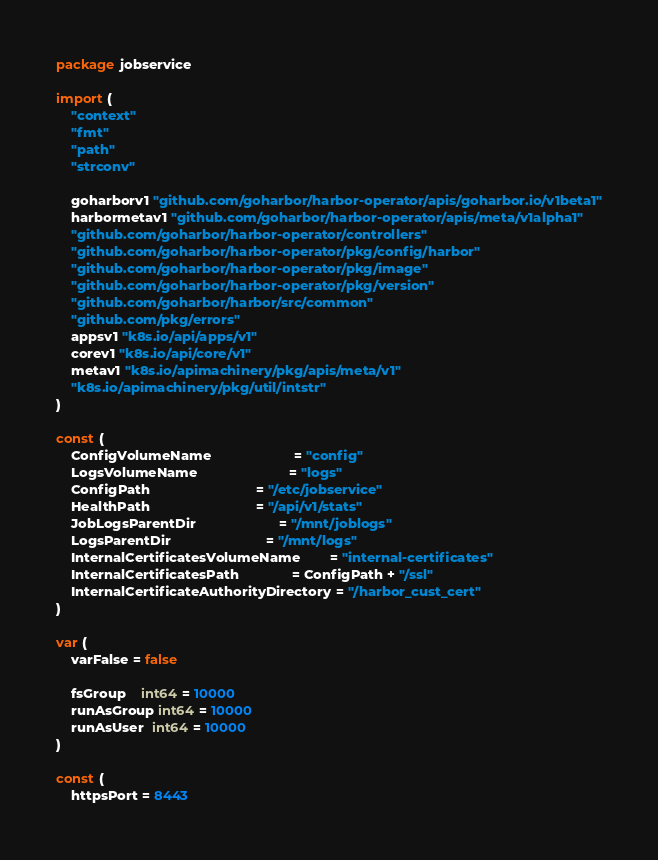Convert code to text. <code><loc_0><loc_0><loc_500><loc_500><_Go_>package jobservice

import (
	"context"
	"fmt"
	"path"
	"strconv"

	goharborv1 "github.com/goharbor/harbor-operator/apis/goharbor.io/v1beta1"
	harbormetav1 "github.com/goharbor/harbor-operator/apis/meta/v1alpha1"
	"github.com/goharbor/harbor-operator/controllers"
	"github.com/goharbor/harbor-operator/pkg/config/harbor"
	"github.com/goharbor/harbor-operator/pkg/image"
	"github.com/goharbor/harbor-operator/pkg/version"
	"github.com/goharbor/harbor/src/common"
	"github.com/pkg/errors"
	appsv1 "k8s.io/api/apps/v1"
	corev1 "k8s.io/api/core/v1"
	metav1 "k8s.io/apimachinery/pkg/apis/meta/v1"
	"k8s.io/apimachinery/pkg/util/intstr"
)

const (
	ConfigVolumeName                      = "config"
	LogsVolumeName                        = "logs"
	ConfigPath                            = "/etc/jobservice"
	HealthPath                            = "/api/v1/stats"
	JobLogsParentDir                      = "/mnt/joblogs"
	LogsParentDir                         = "/mnt/logs"
	InternalCertificatesVolumeName        = "internal-certificates"
	InternalCertificatesPath              = ConfigPath + "/ssl"
	InternalCertificateAuthorityDirectory = "/harbor_cust_cert"
)

var (
	varFalse = false

	fsGroup    int64 = 10000
	runAsGroup int64 = 10000
	runAsUser  int64 = 10000
)

const (
	httpsPort = 8443</code> 